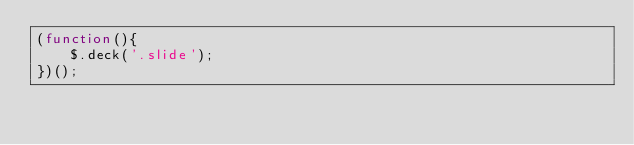<code> <loc_0><loc_0><loc_500><loc_500><_JavaScript_>(function(){
    $.deck('.slide'); 
})();
</code> 